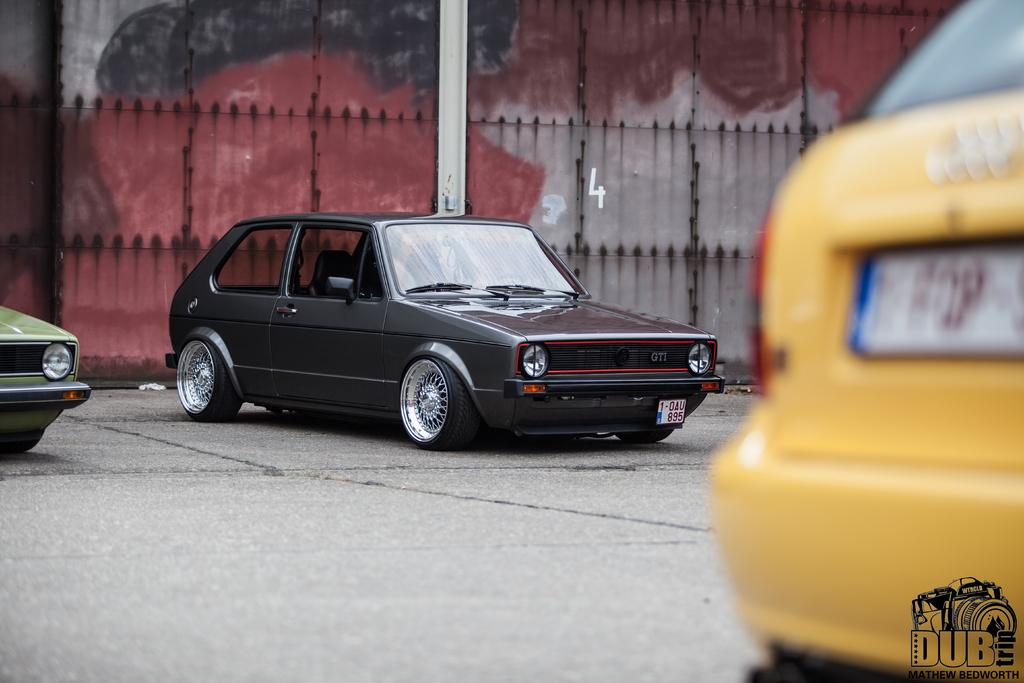<image>
Describe the image concisely. A "DUB" logo appears over the bumper of a yellow car. 